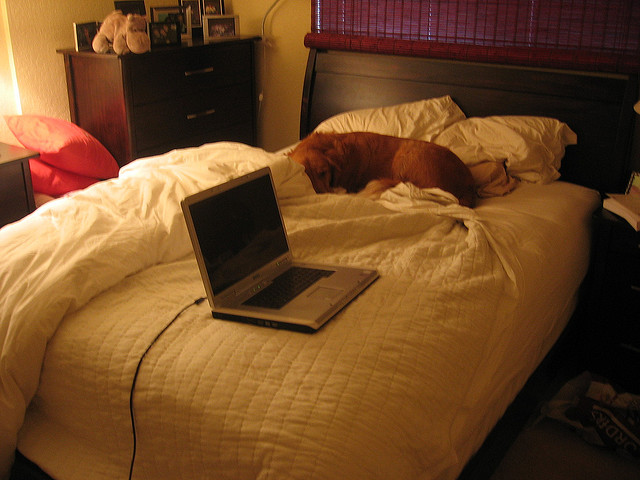<image>What print is on the bed sheets? There is no print on the bed sheets. However, it could be checkered, striped or plain. What print is on the bed sheets? I don't know what print is on the bed sheets. 